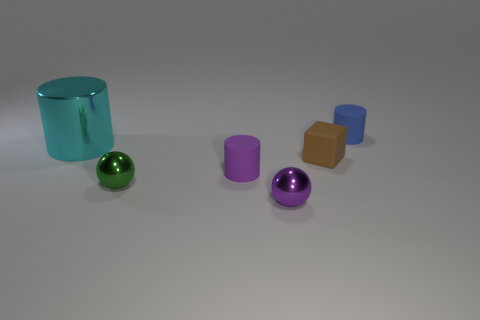There is a small blue object that is the same shape as the cyan shiny thing; what is it made of?
Give a very brief answer. Rubber. Are there any small purple spheres that are on the right side of the tiny purple object to the left of the metal thing in front of the green shiny sphere?
Your answer should be very brief. Yes. There is a big cyan thing; is its shape the same as the tiny shiny thing that is behind the small purple shiny object?
Your response must be concise. No. Is there any other thing that has the same color as the big shiny object?
Your answer should be compact. No. Is the color of the small rubber cylinder that is in front of the large cyan object the same as the tiny metal thing in front of the green metallic thing?
Make the answer very short. Yes. Are any small matte objects visible?
Make the answer very short. Yes. Is there a purple object that has the same material as the small blue object?
Provide a short and direct response. Yes. The shiny cylinder is what color?
Offer a very short reply. Cyan. There is a cube that is the same size as the purple matte cylinder; what color is it?
Your answer should be very brief. Brown. How many metallic things are brown blocks or purple things?
Make the answer very short. 1. 